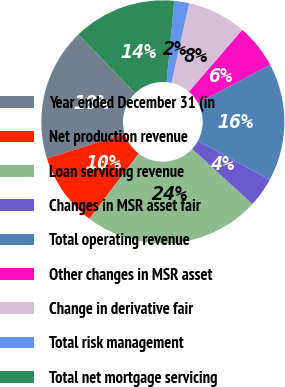Convert chart. <chart><loc_0><loc_0><loc_500><loc_500><pie_chart><fcel>Year ended December 31 (in<fcel>Net production revenue<fcel>Loan servicing revenue<fcel>Changes in MSR asset fair<fcel>Total operating revenue<fcel>Other changes in MSR asset<fcel>Change in derivative fair<fcel>Total risk management<fcel>Total net mortgage servicing<nl><fcel>17.64%<fcel>9.81%<fcel>23.51%<fcel>3.93%<fcel>15.68%<fcel>5.89%<fcel>7.85%<fcel>1.97%<fcel>13.72%<nl></chart> 